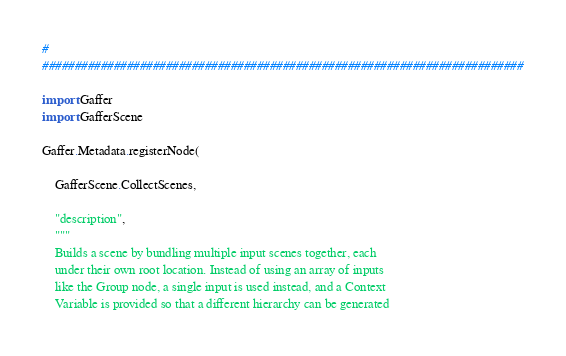Convert code to text. <code><loc_0><loc_0><loc_500><loc_500><_Python_>#
##########################################################################

import Gaffer
import GafferScene

Gaffer.Metadata.registerNode(

	GafferScene.CollectScenes,

	"description",
	"""
	Builds a scene by bundling multiple input scenes together, each
	under their own root location. Instead of using an array of inputs
	like the Group node, a single input is used instead, and a Context
	Variable is provided so that a different hierarchy can be generated</code> 